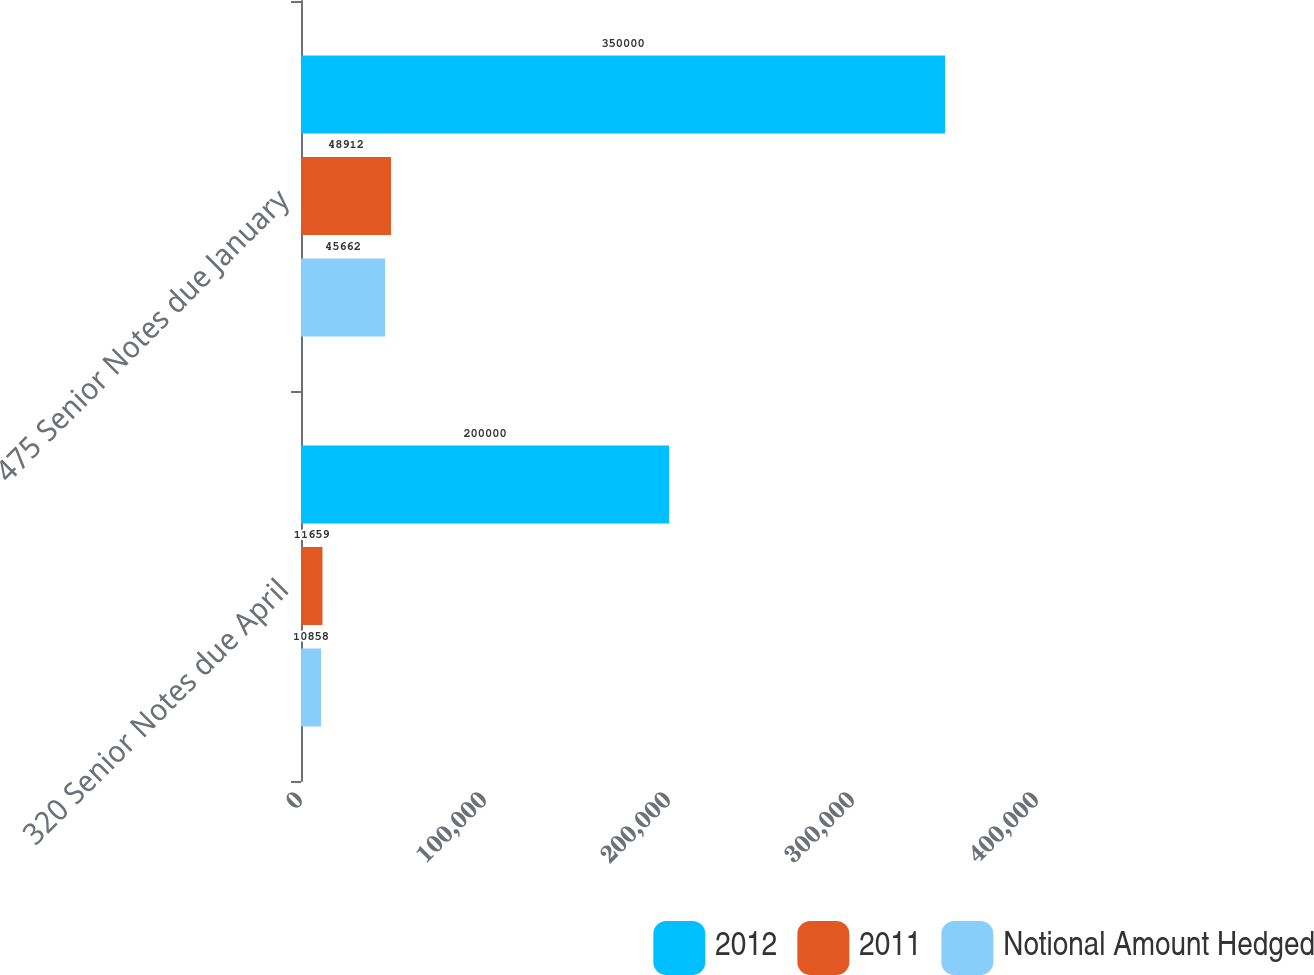Convert chart. <chart><loc_0><loc_0><loc_500><loc_500><stacked_bar_chart><ecel><fcel>320 Senior Notes due April<fcel>475 Senior Notes due January<nl><fcel>2012<fcel>200000<fcel>350000<nl><fcel>2011<fcel>11659<fcel>48912<nl><fcel>Notional Amount Hedged<fcel>10858<fcel>45662<nl></chart> 